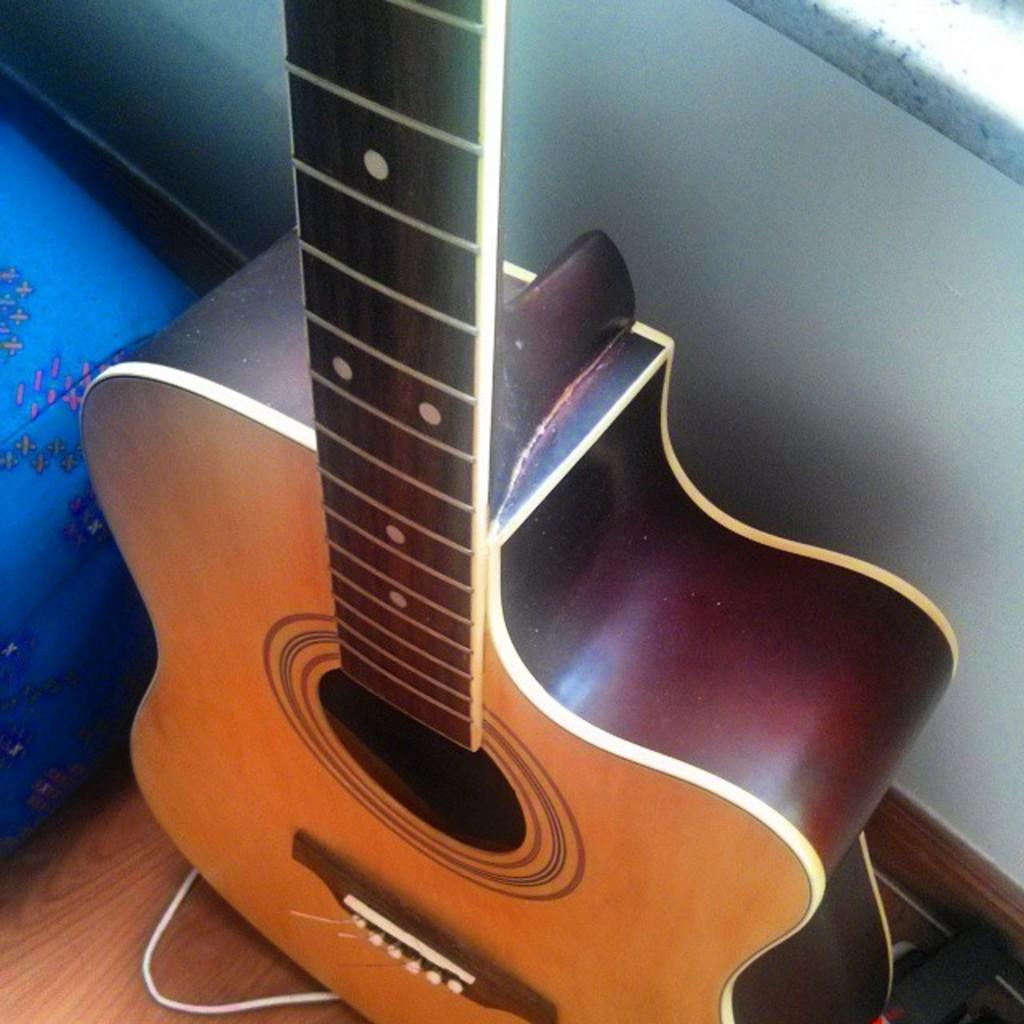What musical instrument is present in the image? There is a guitar in the image. What type of structure can be seen in the background of the image? There is a wall in the image. What type of produce is hanging from the guitar in the image? There is no produce present in the image, and the guitar is not depicted as having anything hanging from it. 